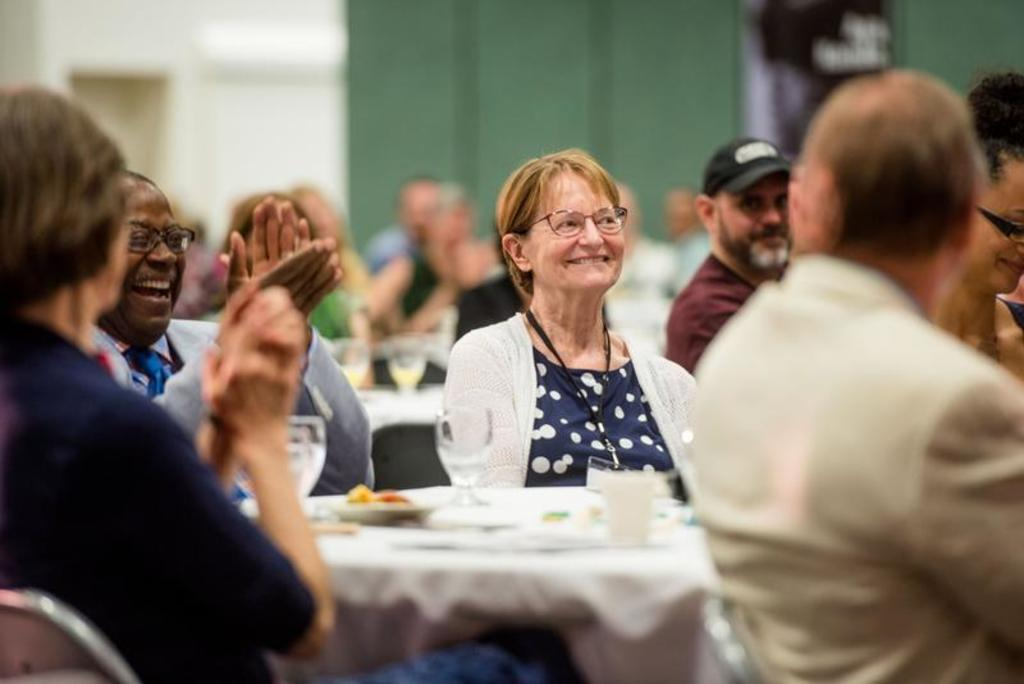How many people are in the image? There is a group of persons in the image. What are the persons in the image doing? The persons are sitting around and applauding someone. What type of trains can be seen in the image? There are no trains present in the image; it features a group of persons sitting and applauding someone. How many toes are visible on the persons in the image? The number of toes visible on the persons in the image cannot be determined from the provided facts. 